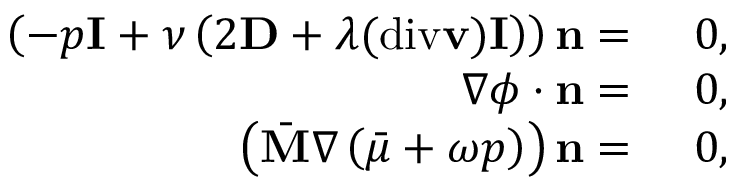Convert formula to latex. <formula><loc_0><loc_0><loc_500><loc_500>\begin{array} { r l } { \left ( - p I + \nu \left ( 2 D + \lambda ( d i v v ) I \right ) \right ) n = } & 0 , } \\ { \nabla \phi \cdot n = } & 0 , } \\ { \left ( \bar { M } \nabla \left ( \bar { \mu } + \omega p \right ) \right ) n = } & 0 , } \end{array}</formula> 